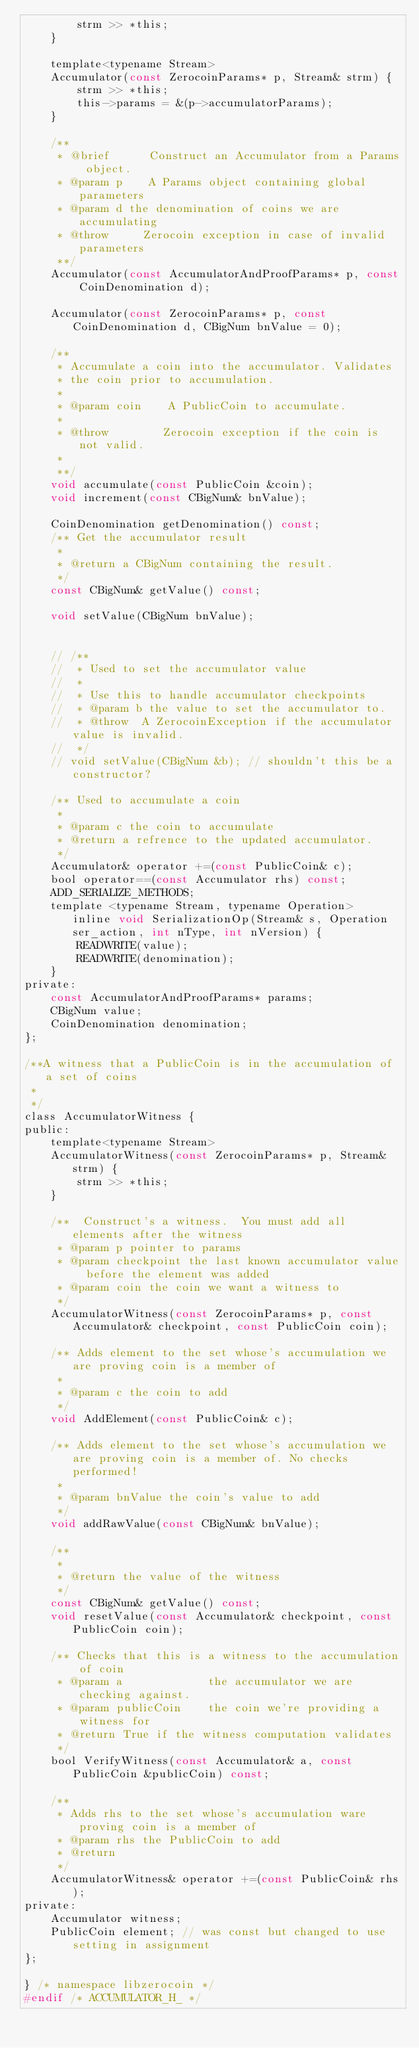<code> <loc_0><loc_0><loc_500><loc_500><_C_>        strm >> *this;
    }

    template<typename Stream>
    Accumulator(const ZerocoinParams* p, Stream& strm) {
        strm >> *this;
        this->params = &(p->accumulatorParams);
    }

    /**
     * @brief      Construct an Accumulator from a Params object.
     * @param p    A Params object containing global parameters
     * @param d the denomination of coins we are accumulating
     * @throw     Zerocoin exception in case of invalid parameters
     **/
    Accumulator(const AccumulatorAndProofParams* p, const CoinDenomination d);

    Accumulator(const ZerocoinParams* p, const CoinDenomination d, CBigNum bnValue = 0);

    /**
     * Accumulate a coin into the accumulator. Validates
     * the coin prior to accumulation.
     *
     * @param coin    A PublicCoin to accumulate.
     *
     * @throw        Zerocoin exception if the coin is not valid.
     *
     **/
    void accumulate(const PublicCoin &coin);
    void increment(const CBigNum& bnValue);

    CoinDenomination getDenomination() const;
    /** Get the accumulator result
     *
     * @return a CBigNum containing the result.
     */
    const CBigNum& getValue() const;

    void setValue(CBigNum bnValue);


    // /**
    //  * Used to set the accumulator value
    //  *
    //  * Use this to handle accumulator checkpoints
    //  * @param b the value to set the accumulator to.
    //  * @throw  A ZerocoinException if the accumulator value is invalid.
    //  */
    // void setValue(CBigNum &b); // shouldn't this be a constructor?

    /** Used to accumulate a coin
     *
     * @param c the coin to accumulate
     * @return a refrence to the updated accumulator.
     */
    Accumulator& operator +=(const PublicCoin& c);
    bool operator==(const Accumulator rhs) const;
    ADD_SERIALIZE_METHODS;
    template <typename Stream, typename Operation>  inline void SerializationOp(Stream& s, Operation ser_action, int nType, int nVersion) {
        READWRITE(value);
        READWRITE(denomination);
    }
private:
    const AccumulatorAndProofParams* params;
    CBigNum value;
    CoinDenomination denomination;
};

/**A witness that a PublicCoin is in the accumulation of a set of coins
 *
 */
class AccumulatorWitness {
public:
    template<typename Stream>
    AccumulatorWitness(const ZerocoinParams* p, Stream& strm) {
        strm >> *this;
    }

    /**  Construct's a witness.  You must add all elements after the witness
     * @param p pointer to params
     * @param checkpoint the last known accumulator value before the element was added
     * @param coin the coin we want a witness to
     */
    AccumulatorWitness(const ZerocoinParams* p, const Accumulator& checkpoint, const PublicCoin coin);

    /** Adds element to the set whose's accumulation we are proving coin is a member of
     *
     * @param c the coin to add
     */
    void AddElement(const PublicCoin& c);

    /** Adds element to the set whose's accumulation we are proving coin is a member of. No checks performed!
     *
     * @param bnValue the coin's value to add
     */
    void addRawValue(const CBigNum& bnValue);

    /**
     *
     * @return the value of the witness
     */
    const CBigNum& getValue() const;
    void resetValue(const Accumulator& checkpoint, const PublicCoin coin);

    /** Checks that this is a witness to the accumulation of coin
     * @param a             the accumulator we are checking against.
     * @param publicCoin    the coin we're providing a witness for
     * @return True if the witness computation validates
     */
    bool VerifyWitness(const Accumulator& a, const PublicCoin &publicCoin) const;

    /**
     * Adds rhs to the set whose's accumulation ware proving coin is a member of
     * @param rhs the PublicCoin to add
     * @return
     */
    AccumulatorWitness& operator +=(const PublicCoin& rhs);
private:
    Accumulator witness;
    PublicCoin element; // was const but changed to use setting in assignment
};

} /* namespace libzerocoin */
#endif /* ACCUMULATOR_H_ */
</code> 